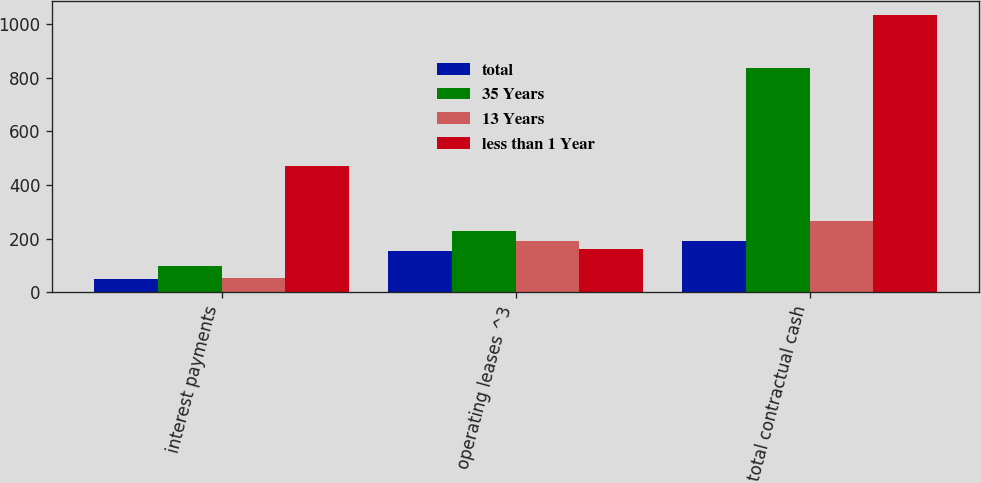<chart> <loc_0><loc_0><loc_500><loc_500><stacked_bar_chart><ecel><fcel>interest payments<fcel>operating leases ^3<fcel>total contractual cash<nl><fcel>total<fcel>50<fcel>152<fcel>191<nl><fcel>35 Years<fcel>99<fcel>229<fcel>837<nl><fcel>13 Years<fcel>52<fcel>191<fcel>264<nl><fcel>less than 1 Year<fcel>472<fcel>162<fcel>1033<nl></chart> 